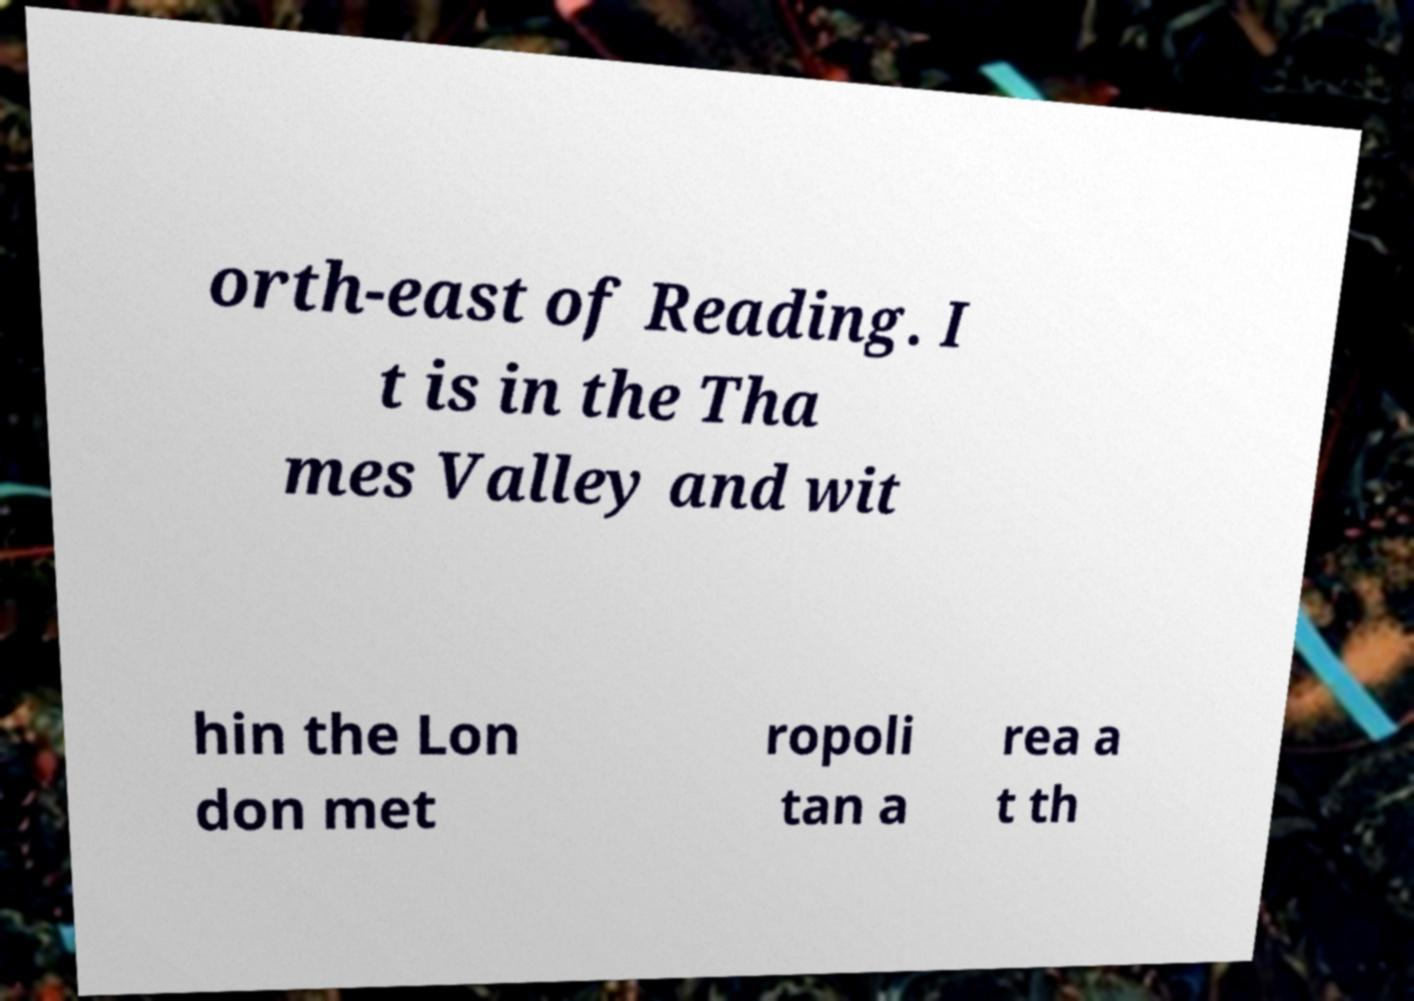I need the written content from this picture converted into text. Can you do that? orth-east of Reading. I t is in the Tha mes Valley and wit hin the Lon don met ropoli tan a rea a t th 